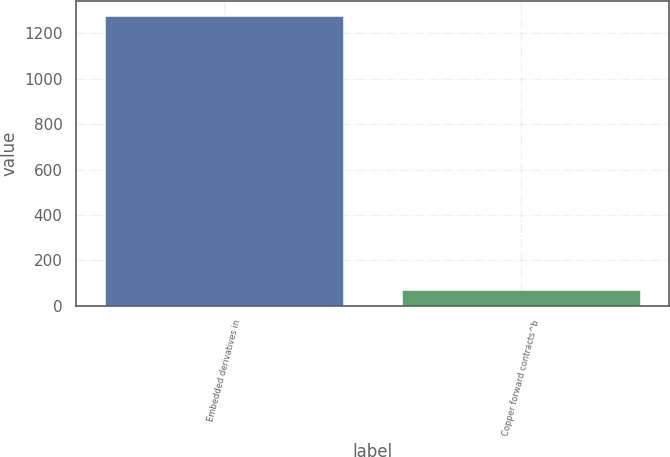Convert chart. <chart><loc_0><loc_0><loc_500><loc_500><bar_chart><fcel>Embedded derivatives in<fcel>Copper forward contracts^b<nl><fcel>1278<fcel>71<nl></chart> 